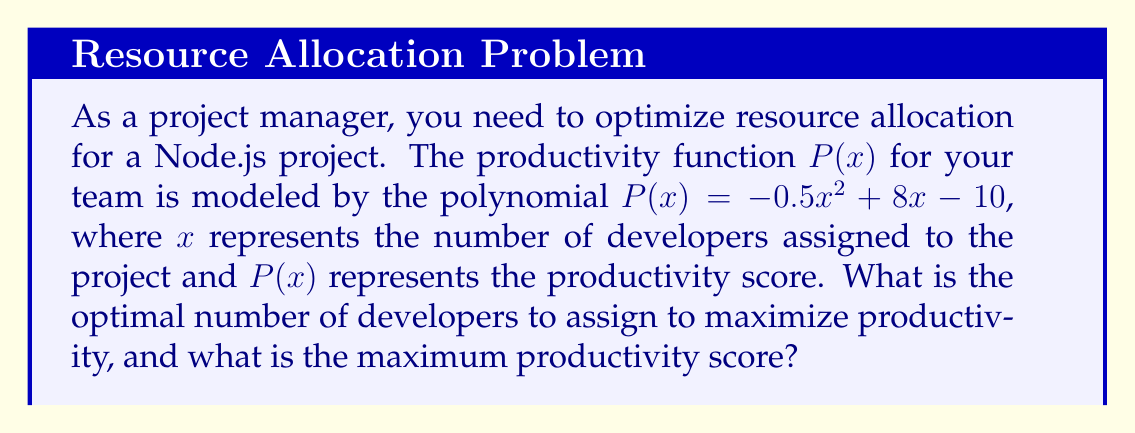Show me your answer to this math problem. To find the optimal number of developers and maximum productivity score, we need to follow these steps:

1. The productivity function is a quadratic polynomial: $P(x) = -0.5x^2 + 8x - 10$

2. To find the maximum value of a quadratic function, we need to find the vertex of the parabola. The x-coordinate of the vertex represents the optimal number of developers, and the y-coordinate represents the maximum productivity score.

3. For a quadratic function in the form $f(x) = ax^2 + bx + c$, the x-coordinate of the vertex is given by $x = -\frac{b}{2a}$

4. In our case, $a = -0.5$, $b = 8$, and $c = -10$

5. Calculating the optimal number of developers:
   $x = -\frac{b}{2a} = -\frac{8}{2(-0.5)} = -\frac{8}{-1} = 8$

6. To find the maximum productivity score, we substitute $x = 8$ into the original function:
   $P(8) = -0.5(8)^2 + 8(8) - 10$
   $= -0.5(64) + 64 - 10$
   $= -32 + 64 - 10$
   $= 22$

Therefore, the optimal number of developers is 8, and the maximum productivity score is 22.
Answer: 8 developers; 22 productivity score 